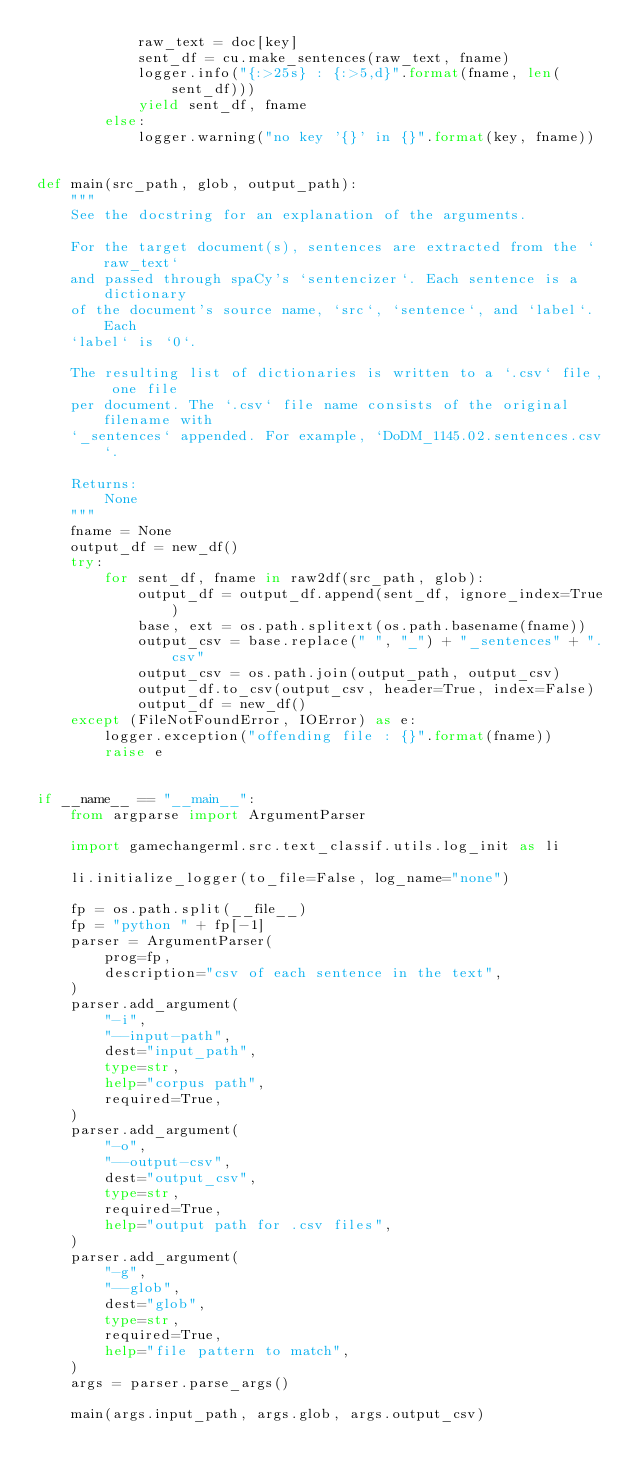Convert code to text. <code><loc_0><loc_0><loc_500><loc_500><_Python_>            raw_text = doc[key]
            sent_df = cu.make_sentences(raw_text, fname)
            logger.info("{:>25s} : {:>5,d}".format(fname, len(sent_df)))
            yield sent_df, fname
        else:
            logger.warning("no key '{}' in {}".format(key, fname))


def main(src_path, glob, output_path):
    """
    See the docstring for an explanation of the arguments.

    For the target document(s), sentences are extracted from the `raw_text`
    and passed through spaCy's `sentencizer`. Each sentence is a dictionary
    of the document's source name, `src`, `sentence`, and `label`. Each
    `label` is `0`.

    The resulting list of dictionaries is written to a `.csv` file, one file
    per document. The `.csv` file name consists of the original filename with
    `_sentences` appended. For example, `DoDM_1145.02.sentences.csv`.

    Returns:
        None
    """
    fname = None
    output_df = new_df()
    try:
        for sent_df, fname in raw2df(src_path, glob):
            output_df = output_df.append(sent_df, ignore_index=True)
            base, ext = os.path.splitext(os.path.basename(fname))
            output_csv = base.replace(" ", "_") + "_sentences" + ".csv"
            output_csv = os.path.join(output_path, output_csv)
            output_df.to_csv(output_csv, header=True, index=False)
            output_df = new_df()
    except (FileNotFoundError, IOError) as e:
        logger.exception("offending file : {}".format(fname))
        raise e


if __name__ == "__main__":
    from argparse import ArgumentParser

    import gamechangerml.src.text_classif.utils.log_init as li

    li.initialize_logger(to_file=False, log_name="none")

    fp = os.path.split(__file__)
    fp = "python " + fp[-1]
    parser = ArgumentParser(
        prog=fp,
        description="csv of each sentence in the text",
    )
    parser.add_argument(
        "-i",
        "--input-path",
        dest="input_path",
        type=str,
        help="corpus path",
        required=True,
    )
    parser.add_argument(
        "-o",
        "--output-csv",
        dest="output_csv",
        type=str,
        required=True,
        help="output path for .csv files",
    )
    parser.add_argument(
        "-g",
        "--glob",
        dest="glob",
        type=str,
        required=True,
        help="file pattern to match",
    )
    args = parser.parse_args()

    main(args.input_path, args.glob, args.output_csv)
</code> 